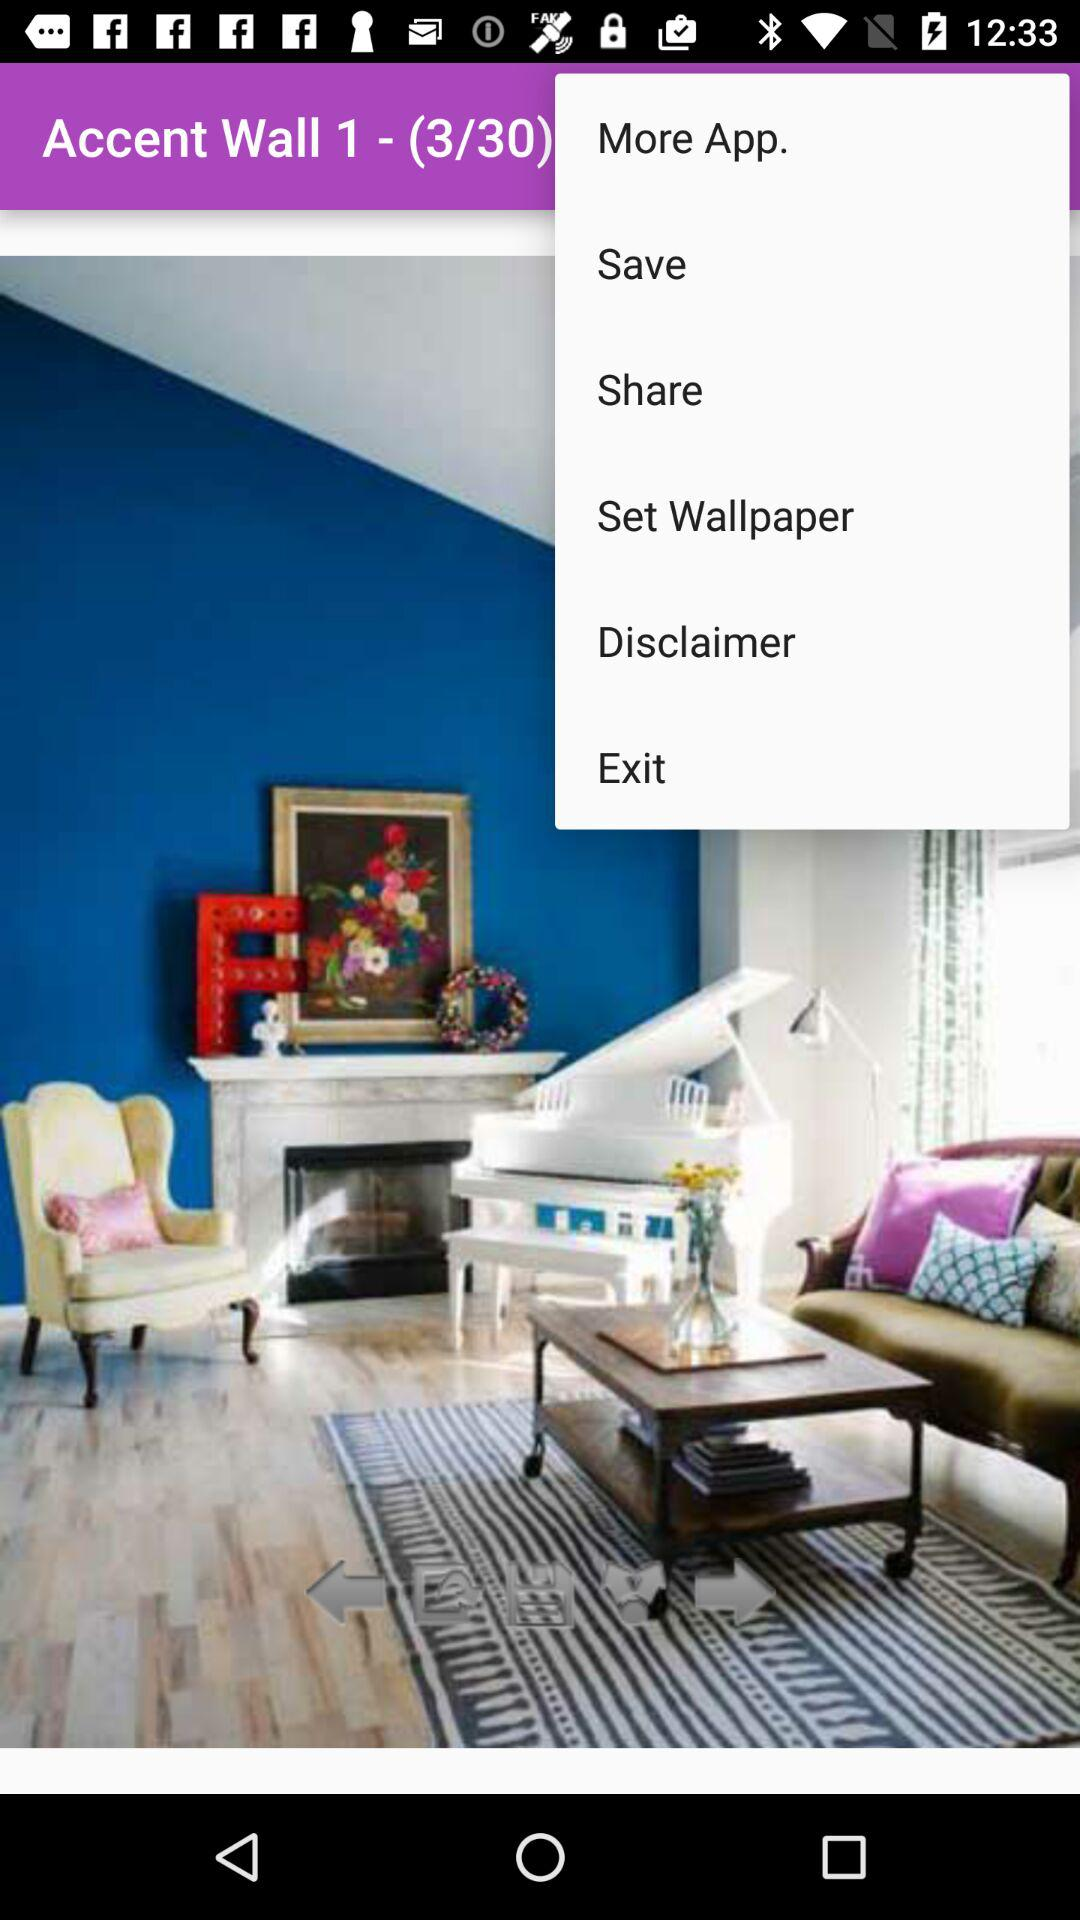Which image number are we currently on? You are currently on the third image number. 